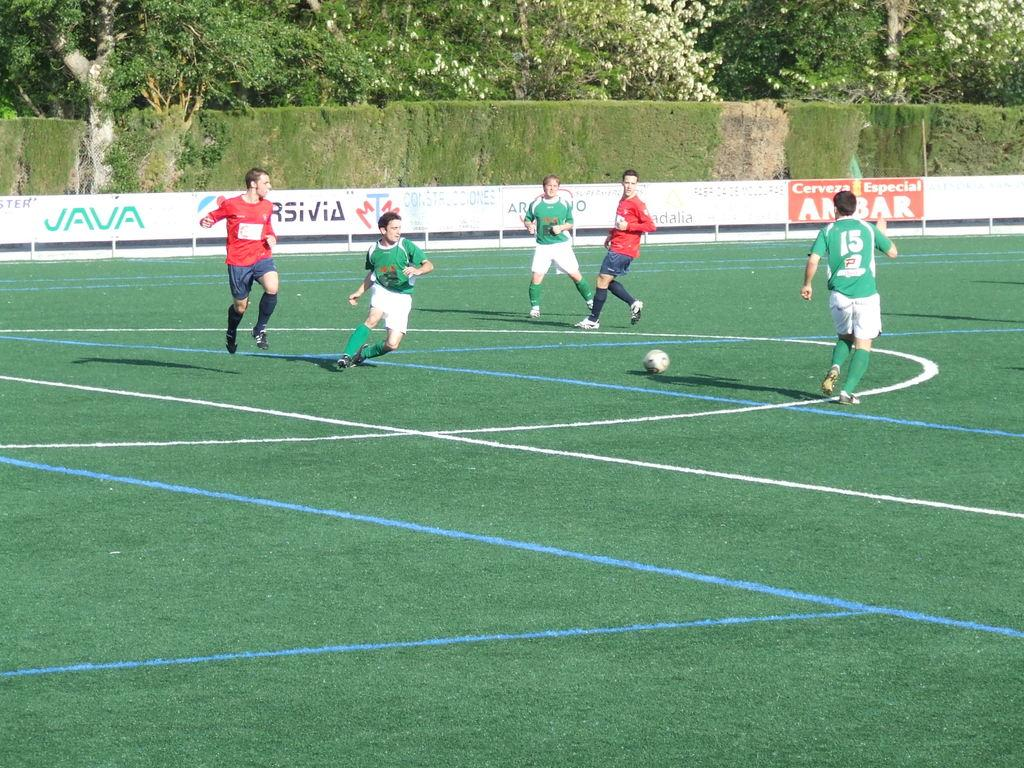<image>
Create a compact narrative representing the image presented. Player number 15 in green looks for the ball in a competitive soccer game. 